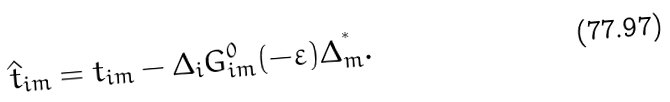<formula> <loc_0><loc_0><loc_500><loc_500>\hat { t } _ { i m } = t _ { i m } - \Delta _ { i } G ^ { 0 } _ { i m } ( - \varepsilon ) \Delta ^ { ^ { * } } _ { m } .</formula> 